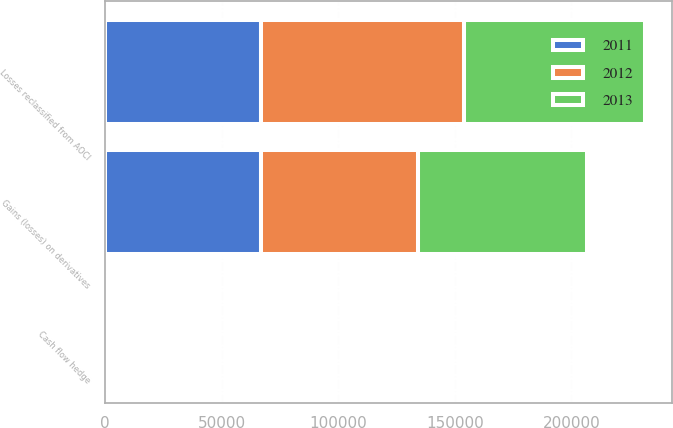<chart> <loc_0><loc_0><loc_500><loc_500><stacked_bar_chart><ecel><fcel>Gains (losses) on derivatives<fcel>Losses reclassified from AOCI<fcel>Cash flow hedge<nl><fcel>2012<fcel>67337<fcel>86894<fcel>879<nl><fcel>2013<fcel>72119<fcel>77731<fcel>480<nl><fcel>2011<fcel>67092<fcel>66847<fcel>491<nl></chart> 